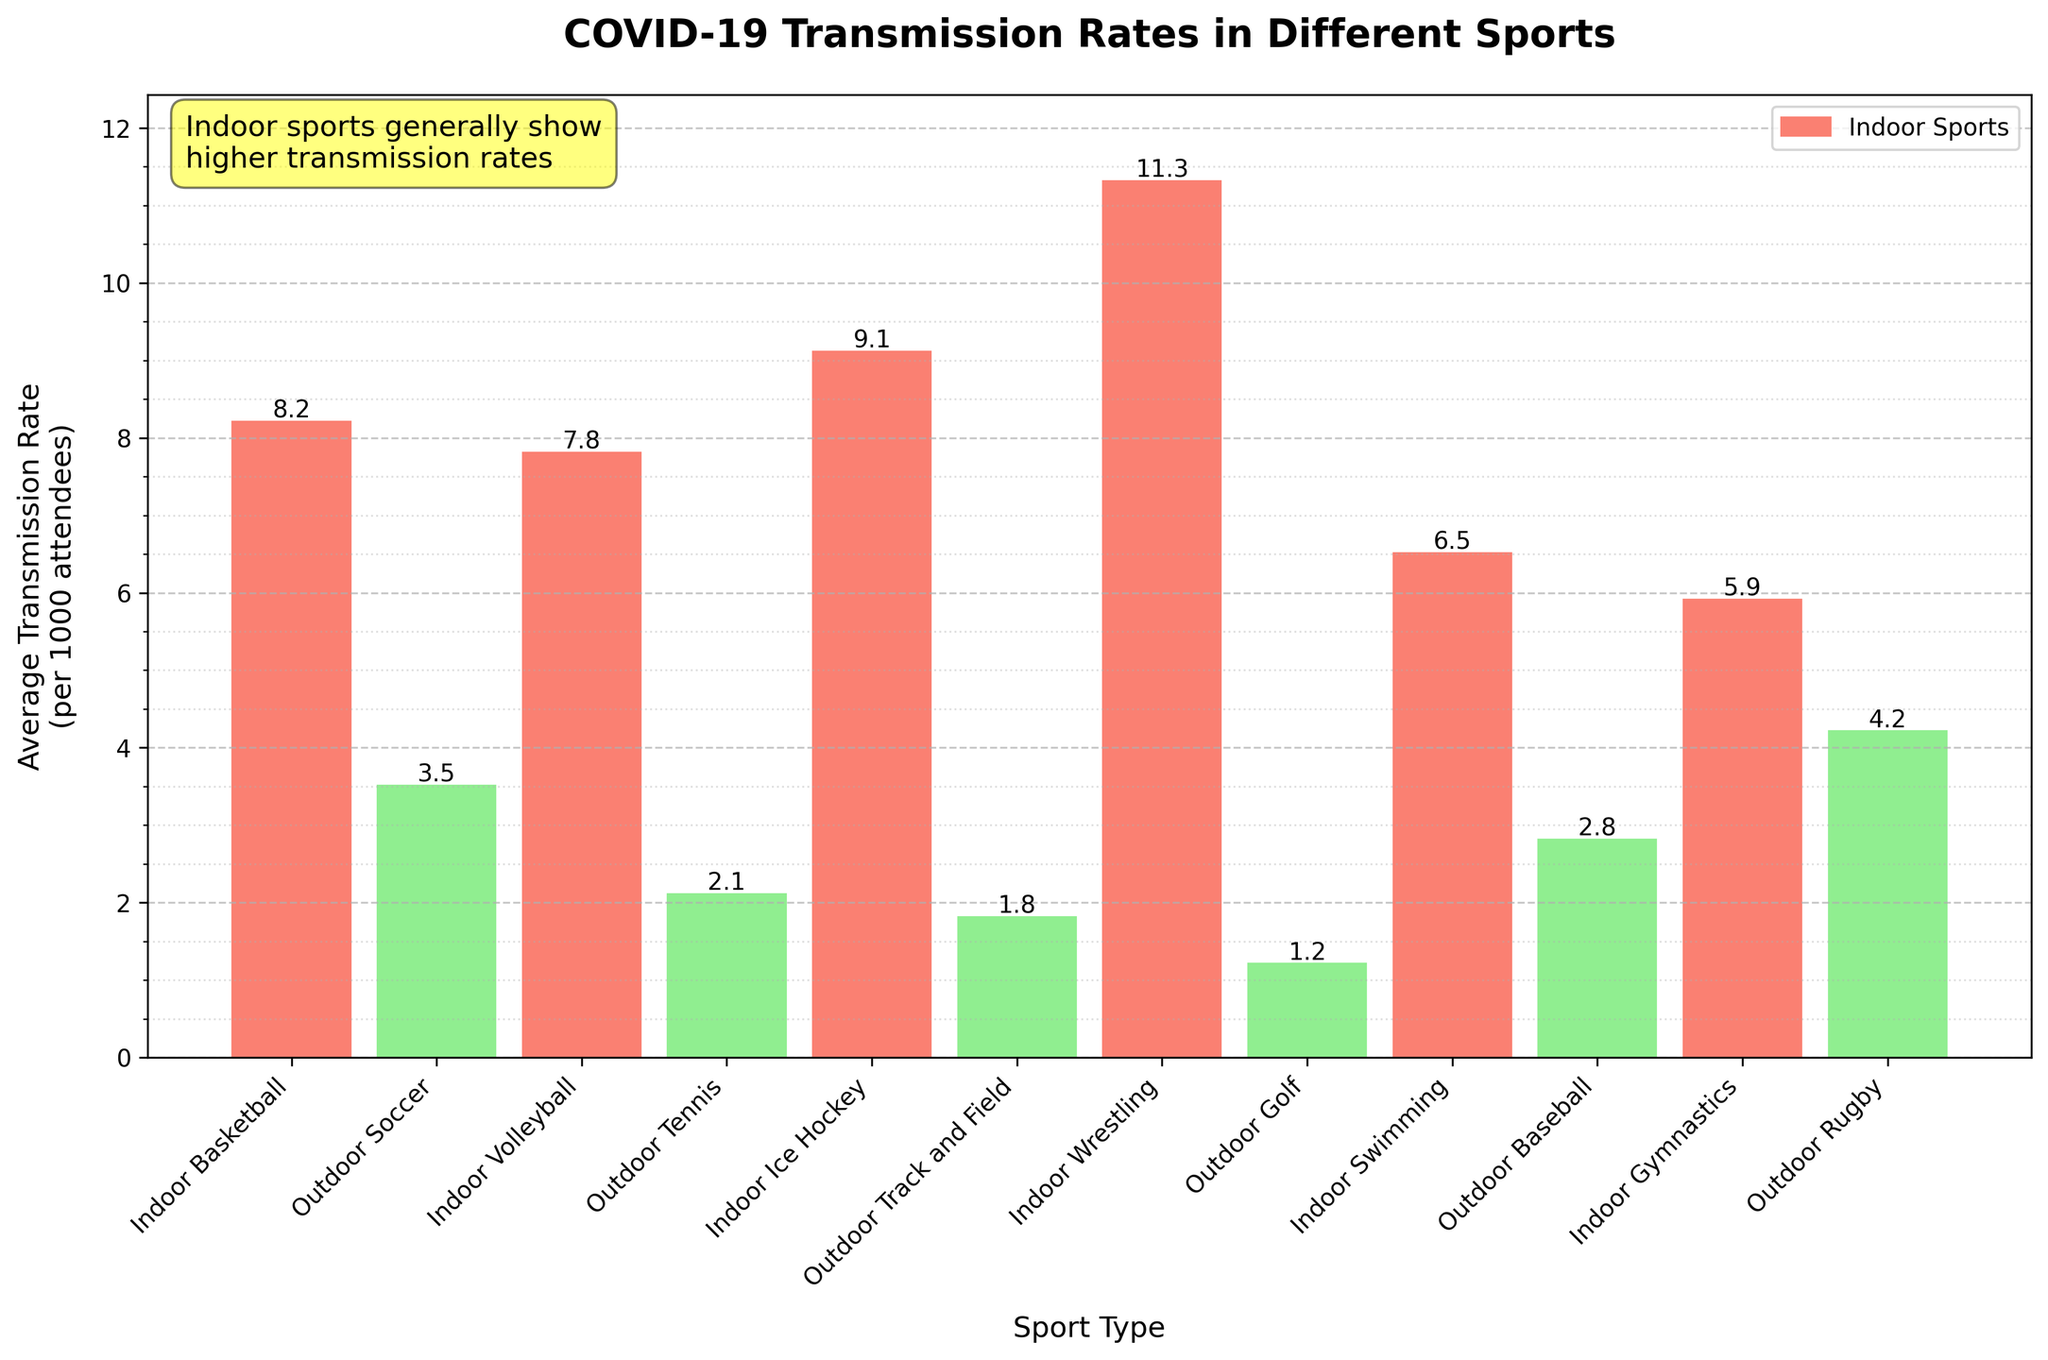What is the average COVID-19 transmission rate for indoor sports? Sum the transmission rates of all indoor sports and divide by the number of indoor sports. (8.2 + 7.8 + 9.1 + 11.3 + 6.5 + 5.9) / 6 = 48.8 / 6
Answer: 8.13 Which sport has the highest COVID-19 transmission rate? Look for the sport with the tallest bar. Indoor Wrestling has the tallest bar with a transmission rate of 11.3.
Answer: Indoor Wrestling How does the average transmission rate of outdoor sports compare to indoor sports? Calculate the average for outdoor sports (sum and divide) and compare it with the average of indoor sports. Outdoor average = (3.5 + 2.1 + 1.8 + 1.2 + 2.8 + 4.2) / 6 = 15.6 / 6 = 2.6. Indoor average = 8.13. Compare 2.6 and 8.13.
Answer: Outdoor sports have a lower average transmission rate What is the difference in transmission rate between Outdoor Soccer and Outdoor Tennis? Find the difference: 3.5 (Outdoor Soccer) - 2.1 (Outdoor Tennis)
Answer: 1.4 List the sports with a transmission rate below 5. Identify bars that are shorter than the reference line at 5. They are: Outdoor Soccer, Outdoor Tennis, Outdoor Track and Field, Outdoor Golf, Outdoor Baseball.
Answer: Outdoor Soccer, Outdoor Tennis, Outdoor Track and Field, Outdoor Golf, Outdoor Baseball What is the total transmission rate for non-contact sports? Sum the transmission rates for non-contact sports based on the data. (Outdoor Tennis + Outdoor Track and Field + Outdoor Golf + Indoor Gymnastics) = (2.1 + 1.8 + 1.2 + 5.9) = 11
Answer: 11 Compare the transmission rates of Indoor Volleyball and Outdoor Rugby. Which one is higher? Look at the bars corresponding to Indoor Volleyball (7.8) and Outdoor Rugby (4.2). Indoor Volleyball has the higher rate.
Answer: Indoor Volleyball Which type of event (indoor or outdoor) has a more consistent transmission rate? Evaluate the spread/variance of transmission rates visually. Indoor sports have more varied heights, whereas outdoor sports appear more consistent.
Answer: Outdoor sports Which indoor sport has the lowest transmission rate, and what is it? Look for the shortest bar among the indoor sports. Indoor Gymnastics with a rate of 5.9.
Answer: Indoor Gymnastics, 5.9 